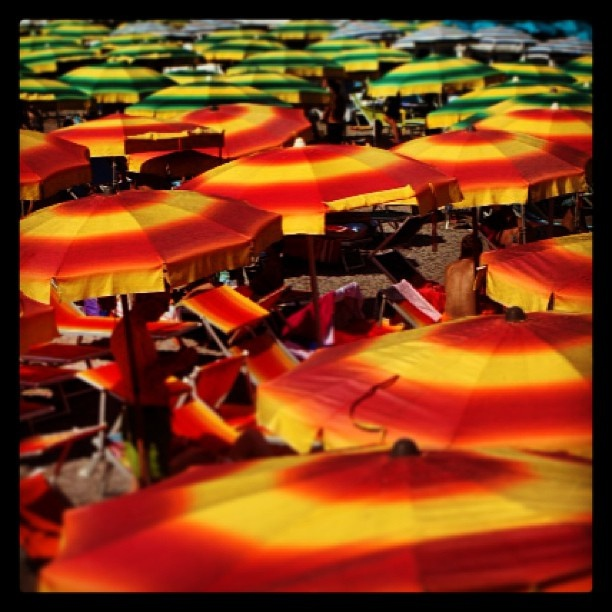Describe the objects in this image and their specific colors. I can see umbrella in black, brown, orange, and red tones, umbrella in black, red, orange, and brown tones, umbrella in black, brown, orange, and red tones, umbrella in black, red, orange, and gold tones, and umbrella in black, orange, red, and brown tones in this image. 